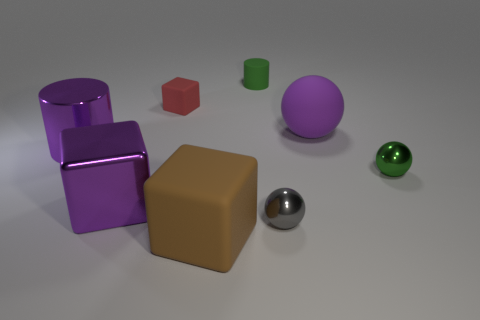Can you describe the lighting of the scene? The lighting in the scene is soft and diffused, casting gentle shadows and highlighting the objects with a subtle glow that suggests an overcast or indirect lighting source. 